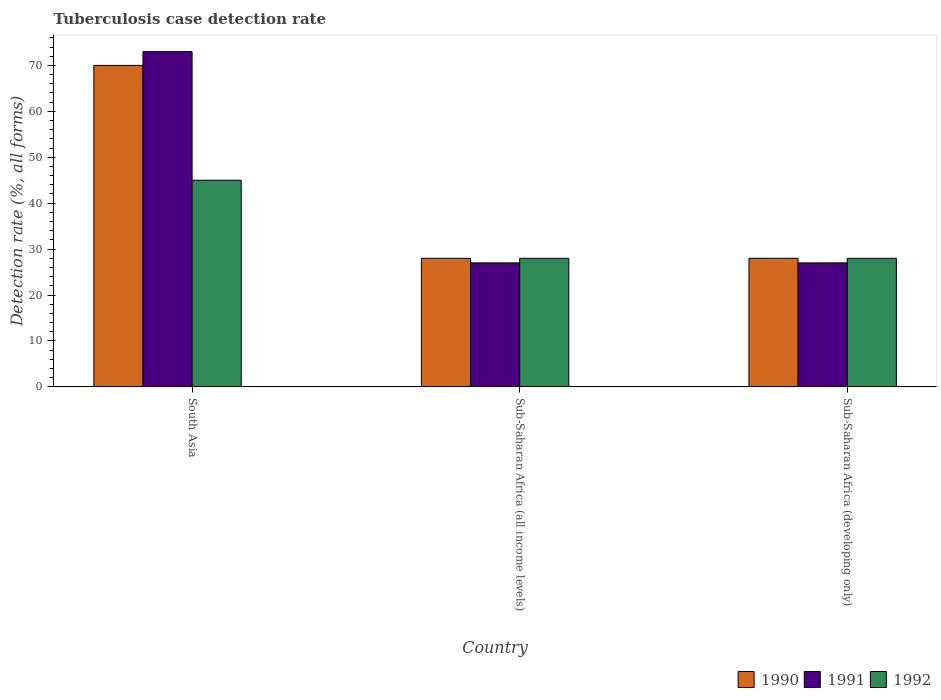Are the number of bars on each tick of the X-axis equal?
Keep it short and to the point. Yes. How many bars are there on the 3rd tick from the left?
Your answer should be compact. 3. What is the label of the 1st group of bars from the left?
Offer a terse response. South Asia. Across all countries, what is the maximum tuberculosis case detection rate in in 1990?
Your response must be concise. 70. Across all countries, what is the minimum tuberculosis case detection rate in in 1991?
Offer a very short reply. 27. In which country was the tuberculosis case detection rate in in 1992 maximum?
Provide a succinct answer. South Asia. In which country was the tuberculosis case detection rate in in 1991 minimum?
Your response must be concise. Sub-Saharan Africa (all income levels). What is the total tuberculosis case detection rate in in 1991 in the graph?
Make the answer very short. 127. What is the difference between the tuberculosis case detection rate in in 1990 in South Asia and that in Sub-Saharan Africa (developing only)?
Give a very brief answer. 42. What is the difference between the tuberculosis case detection rate in in 1990 in Sub-Saharan Africa (all income levels) and the tuberculosis case detection rate in in 1991 in South Asia?
Give a very brief answer. -45. What is the average tuberculosis case detection rate in in 1990 per country?
Provide a succinct answer. 42. What is the difference between the tuberculosis case detection rate in of/in 1990 and tuberculosis case detection rate in of/in 1992 in Sub-Saharan Africa (all income levels)?
Give a very brief answer. 0. In how many countries, is the tuberculosis case detection rate in in 1990 greater than 64 %?
Provide a short and direct response. 1. What is the ratio of the tuberculosis case detection rate in in 1992 in South Asia to that in Sub-Saharan Africa (developing only)?
Give a very brief answer. 1.61. Is the tuberculosis case detection rate in in 1990 in South Asia less than that in Sub-Saharan Africa (all income levels)?
Make the answer very short. No. Is the difference between the tuberculosis case detection rate in in 1990 in South Asia and Sub-Saharan Africa (developing only) greater than the difference between the tuberculosis case detection rate in in 1992 in South Asia and Sub-Saharan Africa (developing only)?
Ensure brevity in your answer.  Yes. What is the difference between the highest and the second highest tuberculosis case detection rate in in 1990?
Keep it short and to the point. -42. In how many countries, is the tuberculosis case detection rate in in 1991 greater than the average tuberculosis case detection rate in in 1991 taken over all countries?
Give a very brief answer. 1. Is the sum of the tuberculosis case detection rate in in 1990 in South Asia and Sub-Saharan Africa (developing only) greater than the maximum tuberculosis case detection rate in in 1992 across all countries?
Provide a short and direct response. Yes. Is it the case that in every country, the sum of the tuberculosis case detection rate in in 1992 and tuberculosis case detection rate in in 1990 is greater than the tuberculosis case detection rate in in 1991?
Keep it short and to the point. Yes. What is the title of the graph?
Your answer should be compact. Tuberculosis case detection rate. What is the label or title of the X-axis?
Your answer should be very brief. Country. What is the label or title of the Y-axis?
Your answer should be compact. Detection rate (%, all forms). What is the Detection rate (%, all forms) in 1991 in South Asia?
Provide a succinct answer. 73. What is the Detection rate (%, all forms) in 1992 in South Asia?
Give a very brief answer. 45. What is the Detection rate (%, all forms) in 1992 in Sub-Saharan Africa (all income levels)?
Your answer should be compact. 28. What is the Detection rate (%, all forms) in 1990 in Sub-Saharan Africa (developing only)?
Offer a terse response. 28. What is the Detection rate (%, all forms) of 1992 in Sub-Saharan Africa (developing only)?
Make the answer very short. 28. Across all countries, what is the maximum Detection rate (%, all forms) of 1990?
Your answer should be compact. 70. Across all countries, what is the maximum Detection rate (%, all forms) of 1992?
Your response must be concise. 45. Across all countries, what is the minimum Detection rate (%, all forms) in 1991?
Your response must be concise. 27. Across all countries, what is the minimum Detection rate (%, all forms) in 1992?
Make the answer very short. 28. What is the total Detection rate (%, all forms) in 1990 in the graph?
Your response must be concise. 126. What is the total Detection rate (%, all forms) of 1991 in the graph?
Provide a succinct answer. 127. What is the total Detection rate (%, all forms) of 1992 in the graph?
Keep it short and to the point. 101. What is the difference between the Detection rate (%, all forms) of 1990 in South Asia and that in Sub-Saharan Africa (all income levels)?
Make the answer very short. 42. What is the difference between the Detection rate (%, all forms) in 1990 in South Asia and that in Sub-Saharan Africa (developing only)?
Your answer should be very brief. 42. What is the difference between the Detection rate (%, all forms) of 1992 in South Asia and that in Sub-Saharan Africa (developing only)?
Provide a succinct answer. 17. What is the difference between the Detection rate (%, all forms) of 1991 in South Asia and the Detection rate (%, all forms) of 1992 in Sub-Saharan Africa (all income levels)?
Offer a terse response. 45. What is the difference between the Detection rate (%, all forms) of 1990 in South Asia and the Detection rate (%, all forms) of 1991 in Sub-Saharan Africa (developing only)?
Give a very brief answer. 43. What is the difference between the Detection rate (%, all forms) of 1990 in Sub-Saharan Africa (all income levels) and the Detection rate (%, all forms) of 1991 in Sub-Saharan Africa (developing only)?
Your answer should be very brief. 1. What is the difference between the Detection rate (%, all forms) of 1991 in Sub-Saharan Africa (all income levels) and the Detection rate (%, all forms) of 1992 in Sub-Saharan Africa (developing only)?
Provide a succinct answer. -1. What is the average Detection rate (%, all forms) of 1991 per country?
Your answer should be compact. 42.33. What is the average Detection rate (%, all forms) of 1992 per country?
Give a very brief answer. 33.67. What is the difference between the Detection rate (%, all forms) of 1990 and Detection rate (%, all forms) of 1991 in South Asia?
Keep it short and to the point. -3. What is the difference between the Detection rate (%, all forms) of 1990 and Detection rate (%, all forms) of 1992 in South Asia?
Your answer should be very brief. 25. What is the difference between the Detection rate (%, all forms) of 1990 and Detection rate (%, all forms) of 1991 in Sub-Saharan Africa (all income levels)?
Your answer should be very brief. 1. What is the difference between the Detection rate (%, all forms) in 1990 and Detection rate (%, all forms) in 1992 in Sub-Saharan Africa (all income levels)?
Give a very brief answer. 0. What is the difference between the Detection rate (%, all forms) of 1991 and Detection rate (%, all forms) of 1992 in Sub-Saharan Africa (all income levels)?
Keep it short and to the point. -1. What is the ratio of the Detection rate (%, all forms) of 1990 in South Asia to that in Sub-Saharan Africa (all income levels)?
Provide a short and direct response. 2.5. What is the ratio of the Detection rate (%, all forms) in 1991 in South Asia to that in Sub-Saharan Africa (all income levels)?
Make the answer very short. 2.7. What is the ratio of the Detection rate (%, all forms) of 1992 in South Asia to that in Sub-Saharan Africa (all income levels)?
Offer a terse response. 1.61. What is the ratio of the Detection rate (%, all forms) in 1990 in South Asia to that in Sub-Saharan Africa (developing only)?
Keep it short and to the point. 2.5. What is the ratio of the Detection rate (%, all forms) of 1991 in South Asia to that in Sub-Saharan Africa (developing only)?
Provide a succinct answer. 2.7. What is the ratio of the Detection rate (%, all forms) of 1992 in South Asia to that in Sub-Saharan Africa (developing only)?
Keep it short and to the point. 1.61. What is the ratio of the Detection rate (%, all forms) of 1990 in Sub-Saharan Africa (all income levels) to that in Sub-Saharan Africa (developing only)?
Make the answer very short. 1. What is the ratio of the Detection rate (%, all forms) in 1991 in Sub-Saharan Africa (all income levels) to that in Sub-Saharan Africa (developing only)?
Ensure brevity in your answer.  1. What is the ratio of the Detection rate (%, all forms) in 1992 in Sub-Saharan Africa (all income levels) to that in Sub-Saharan Africa (developing only)?
Offer a very short reply. 1. What is the difference between the highest and the second highest Detection rate (%, all forms) in 1990?
Offer a terse response. 42. What is the difference between the highest and the second highest Detection rate (%, all forms) of 1991?
Keep it short and to the point. 46. What is the difference between the highest and the lowest Detection rate (%, all forms) in 1992?
Keep it short and to the point. 17. 